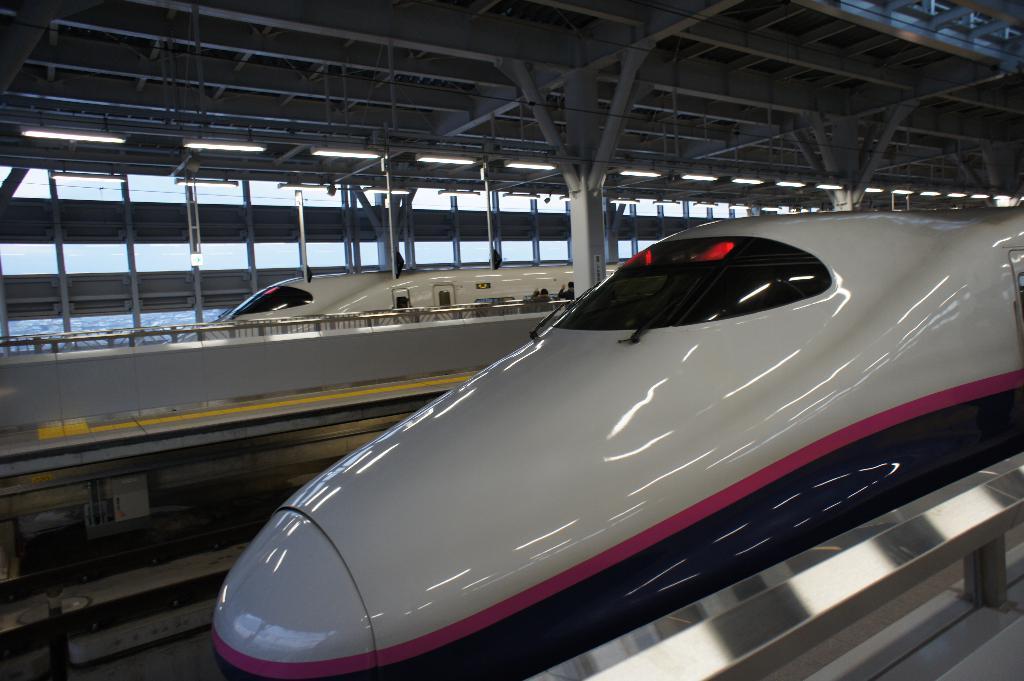Could you give a brief overview of what you see in this image? In the center of the image we can see two metro trains,which are in white color. And we can see fences and few other objects. In the background there is a roof,glass,poles,lights etc. 